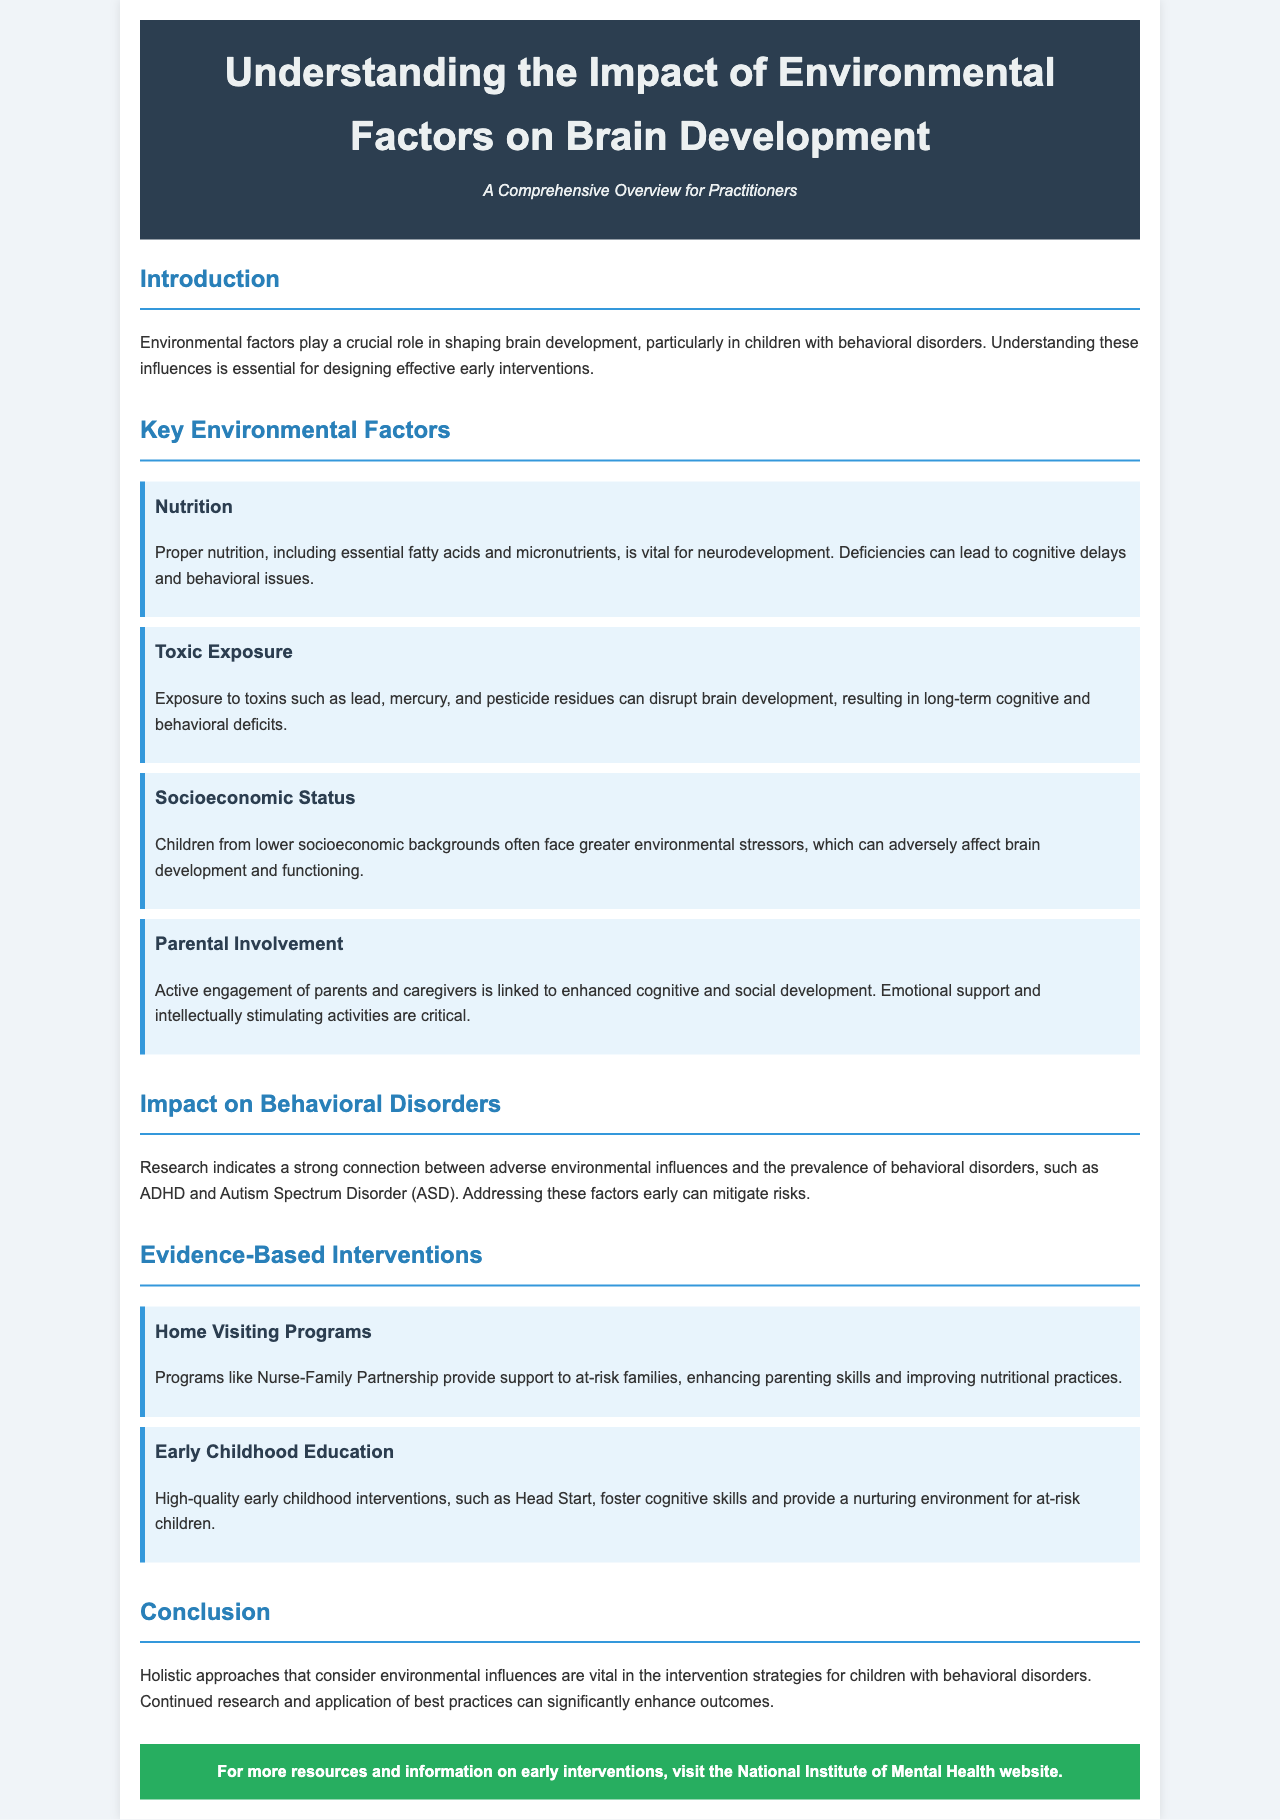What are the key environmental factors influencing brain development? The key environmental factors include Nutrition, Toxic Exposure, Socioeconomic Status, and Parental Involvement.
Answer: Nutrition, Toxic Exposure, Socioeconomic Status, Parental Involvement What is a major impact of adverse environmental influences? Adverse environmental influences strongly connect to the prevalence of behavioral disorders such as ADHD and Autism Spectrum Disorder.
Answer: Behavioral disorders Which program enhances parenting skills in at-risk families? The document mentions the Nurse-Family Partnership as a program that provides support to at-risk families.
Answer: Nurse-Family Partnership What is highlighted as critical for cognitive and social development? Active engagement of parents and caregivers is linked to enhanced cognitive and social development.
Answer: Active engagement What is the primary focus of the brochure? The brochure focuses on understanding the impact of environmental factors on brain development, especially in children with behavioral disorders.
Answer: Impact of environmental factors 